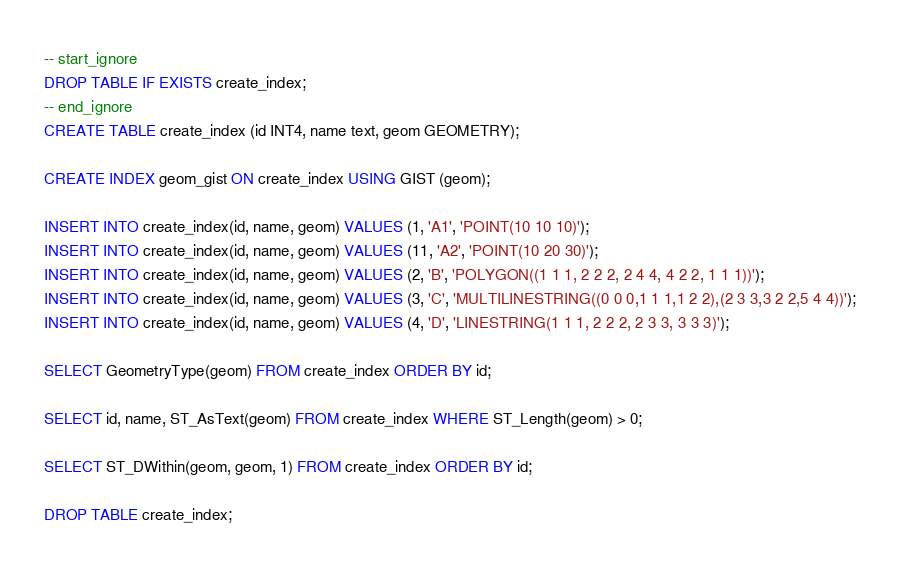<code> <loc_0><loc_0><loc_500><loc_500><_SQL_>-- start_ignore
DROP TABLE IF EXISTS create_index;
-- end_ignore
CREATE TABLE create_index (id INT4, name text, geom GEOMETRY);

CREATE INDEX geom_gist ON create_index USING GIST (geom);

INSERT INTO create_index(id, name, geom) VALUES (1, 'A1', 'POINT(10 10 10)');
INSERT INTO create_index(id, name, geom) VALUES (11, 'A2', 'POINT(10 20 30)');
INSERT INTO create_index(id, name, geom) VALUES (2, 'B', 'POLYGON((1 1 1, 2 2 2, 2 4 4, 4 2 2, 1 1 1))');
INSERT INTO create_index(id, name, geom) VALUES (3, 'C', 'MULTILINESTRING((0 0 0,1 1 1,1 2 2),(2 3 3,3 2 2,5 4 4))');
INSERT INTO create_index(id, name, geom) VALUES (4, 'D', 'LINESTRING(1 1 1, 2 2 2, 2 3 3, 3 3 3)');

SELECT GeometryType(geom) FROM create_index ORDER BY id;

SELECT id, name, ST_AsText(geom) FROM create_index WHERE ST_Length(geom) > 0;

SELECT ST_DWithin(geom, geom, 1) FROM create_index ORDER BY id;

DROP TABLE create_index;

</code> 